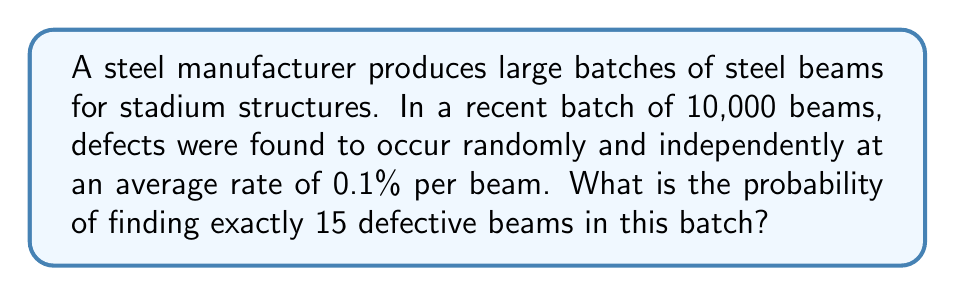Show me your answer to this math problem. To solve this problem, we can use the Poisson distribution, which is appropriate for rare events occurring in large samples. Let's approach this step-by-step:

1) The Poisson distribution is given by the formula:

   $$P(X = k) = \frac{e^{-\lambda} \lambda^k}{k!}$$

   where:
   $\lambda$ is the expected number of occurrences
   $k$ is the number of occurrences we're interested in
   $e$ is Euler's number (approximately 2.71828)

2) First, let's calculate $\lambda$:
   $\lambda = 10,000 \times 0.001 = 10$

3) Now, we want to find $P(X = 15)$, so $k = 15$

4) Plugging these values into the Poisson formula:

   $$P(X = 15) = \frac{e^{-10} 10^{15}}{15!}$$

5) Let's calculate this step-by-step:
   
   $e^{-10} \approx 0.0000454$
   
   $10^{15} = 1,000,000,000,000,000$
   
   $15! = 1,307,674,368,000$

6) Putting it all together:

   $$P(X = 15) = \frac{0.0000454 \times 1,000,000,000,000,000}{1,307,674,368,000} \approx 0.0347$$

7) Therefore, the probability of finding exactly 15 defective beams is approximately 0.0347 or 3.47%.
Answer: 0.0347 